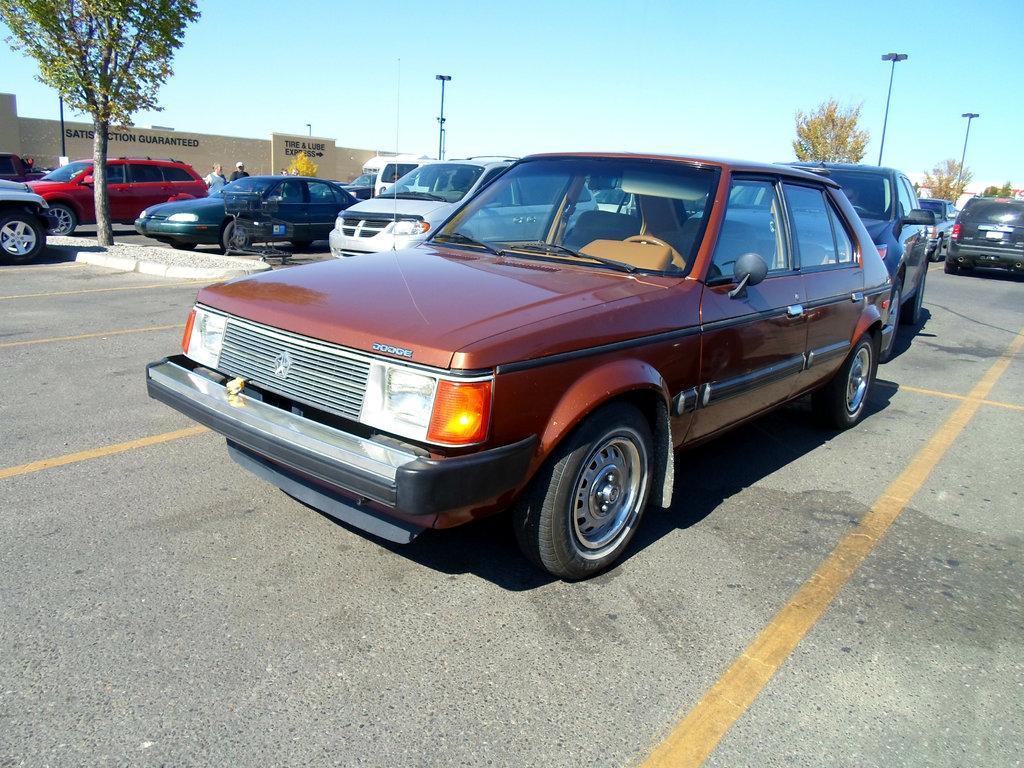How would you summarize this image in a sentence or two? In this image we can see motor vehicles on the road, poles, walls, trees, persons standing and sky. 